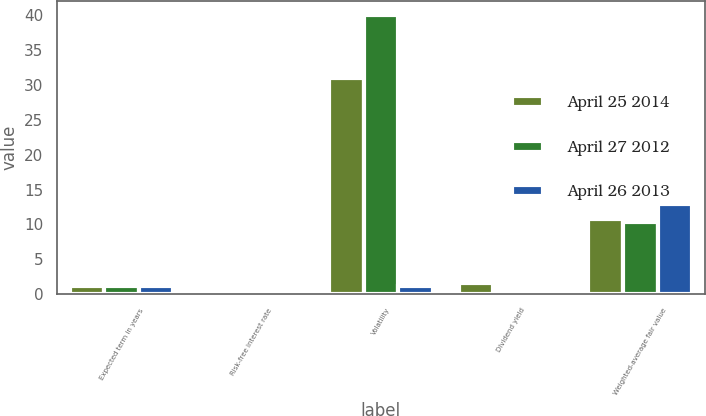<chart> <loc_0><loc_0><loc_500><loc_500><stacked_bar_chart><ecel><fcel>Expected term in years<fcel>Risk-free interest rate<fcel>Volatility<fcel>Dividend yield<fcel>Weighted-average fair value<nl><fcel>April 25 2014<fcel>1.2<fcel>0.2<fcel>31<fcel>1.6<fcel>10.83<nl><fcel>April 27 2012<fcel>1.2<fcel>0.2<fcel>40<fcel>0<fcel>10.36<nl><fcel>April 26 2013<fcel>1.2<fcel>0.2<fcel>1.2<fcel>0<fcel>12.87<nl></chart> 